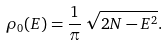Convert formula to latex. <formula><loc_0><loc_0><loc_500><loc_500>\rho _ { 0 } ( E ) = \frac { 1 } { \pi } \, \sqrt { 2 N - E ^ { 2 } } .</formula> 